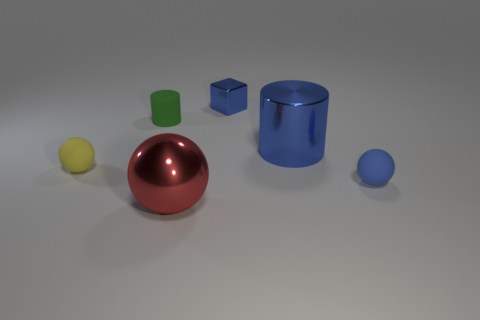Can you tell me about the lighting in the scene? The lighting in the scene seems to be diffused, with a soft shadow cast under each object, indicating the light source is not extremely harsh. It's likely that the lighting is coming from above, as the shadows are more pronounced directly beneath the objects. There is also a subtle reflection on the objects which hints at the presence of either multiple light sources or a well-lit environment. Does the lighting affect the color of the objects? Yes, lighting can significantly affect how we perceive the color of objects. In this scene, the diffuse light softens the shadows and reduces the contrast, potentially making the colors appear more uniform and soft. The hue and saturation of each object could appear different under another lighting condition. 